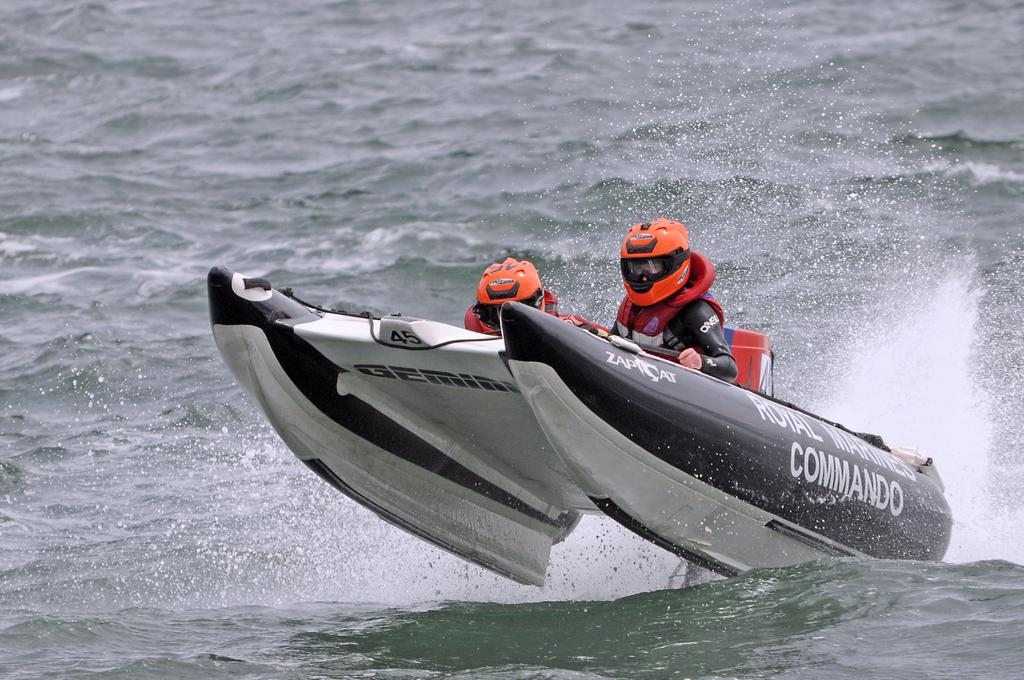How many people are in the image? There are two persons in the image. What are the persons wearing on their heads? The persons are wearing helmets. What are the persons wearing for safety on the water? The persons are wearing life jackets. What type of vehicle are the persons sitting in? The persons are sitting in a boat. Where is the boat placed in the image? The boat is placed on the water. What time of day is it in the image, considering the presence of night? There is no mention of night or any indication of the time of day in the image. 